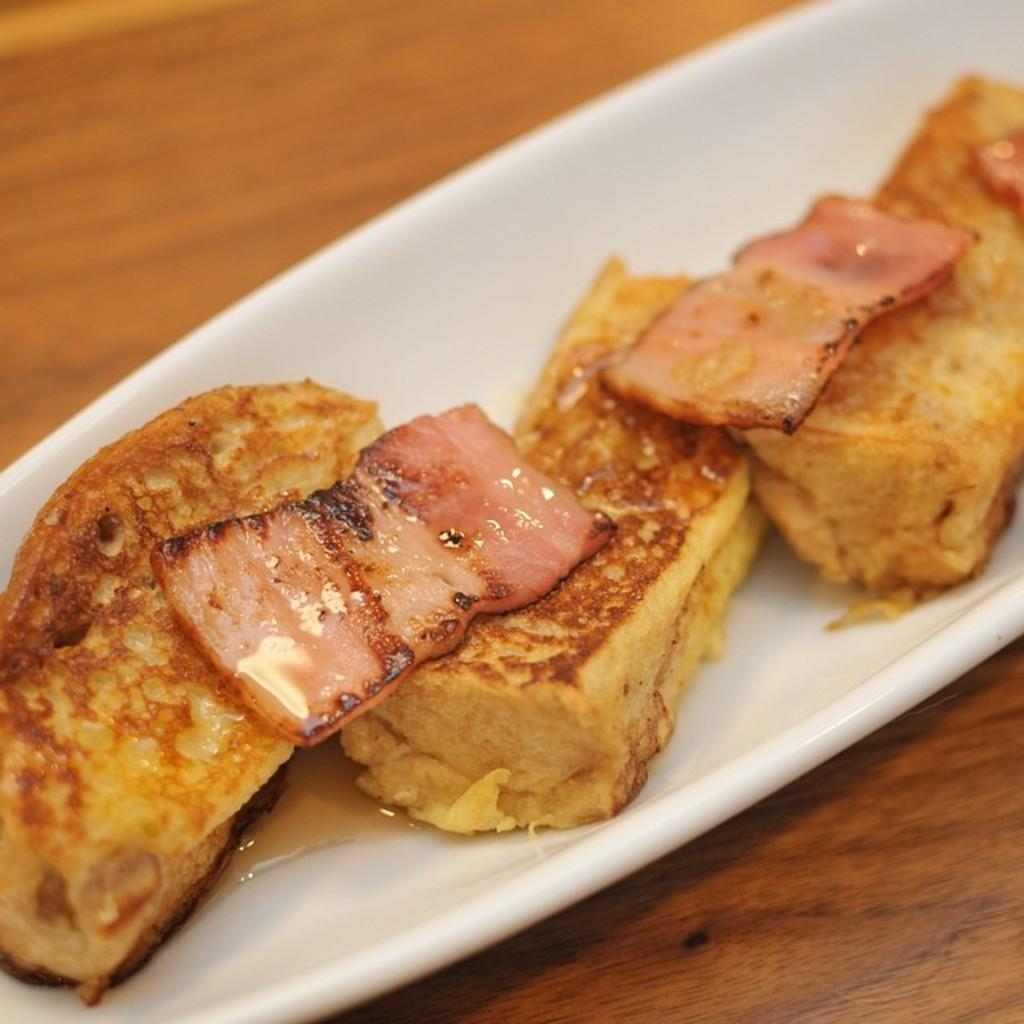What is in the bowl that is visible in the image? There is a bowl with food items in it. On what is the bowl placed in the image? The bowl is placed on a table. What type of glue is being used to hold the feet together in the image? There is no glue or feet present in the image; it features a bowl with food items placed on a table. 